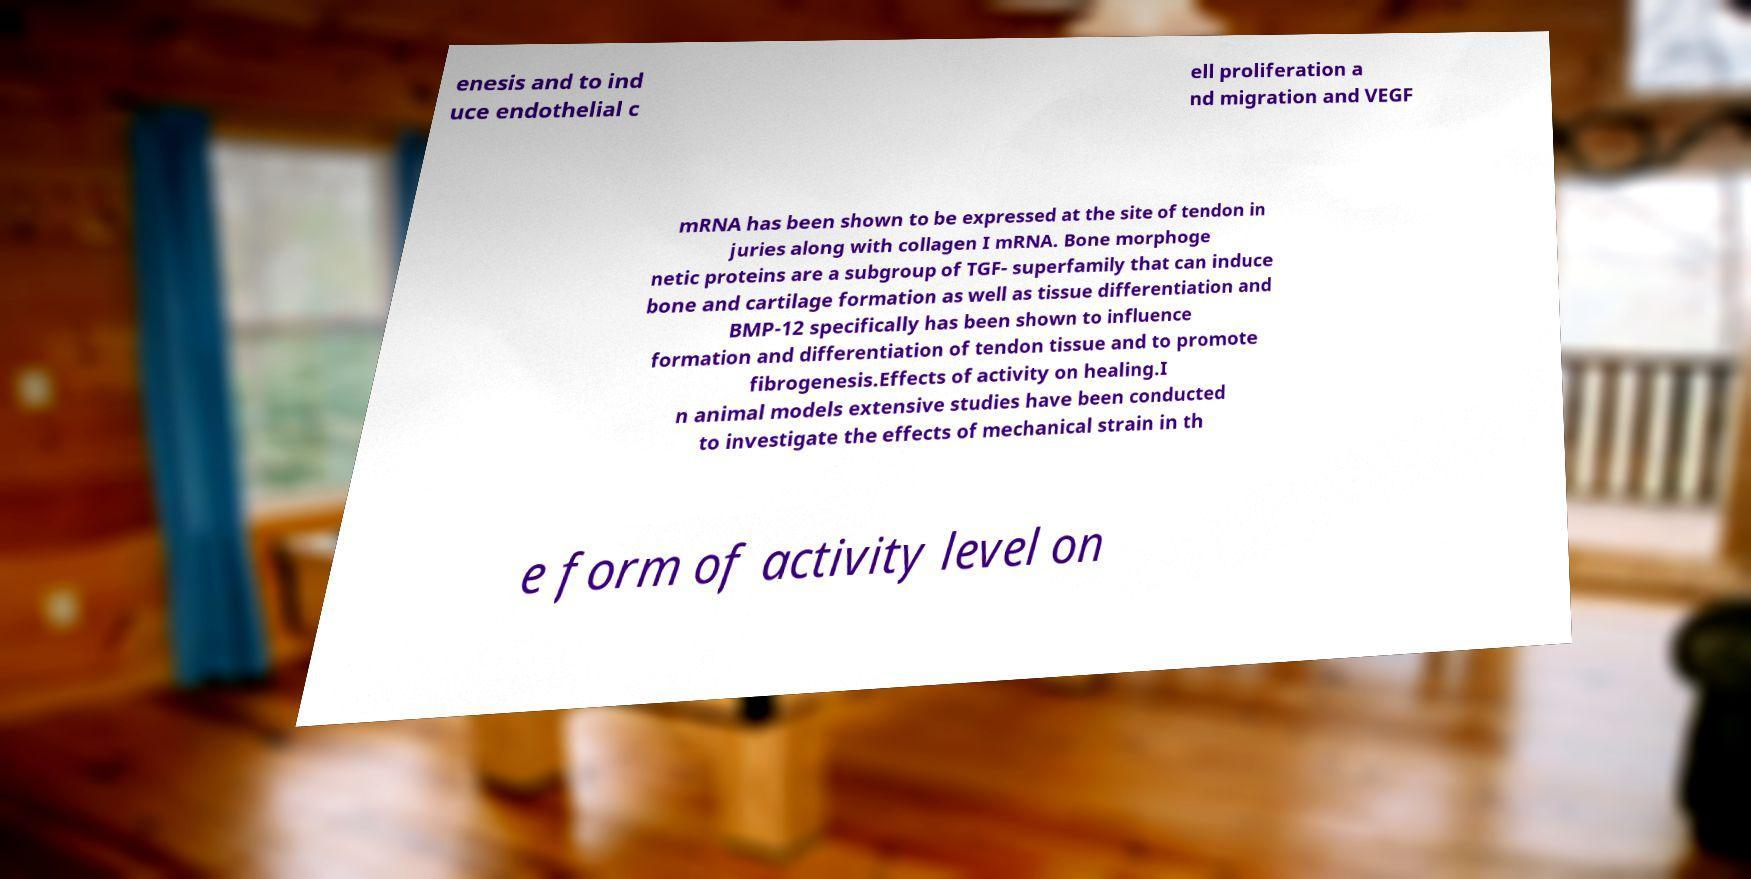Can you read and provide the text displayed in the image?This photo seems to have some interesting text. Can you extract and type it out for me? enesis and to ind uce endothelial c ell proliferation a nd migration and VEGF mRNA has been shown to be expressed at the site of tendon in juries along with collagen I mRNA. Bone morphoge netic proteins are a subgroup of TGF- superfamily that can induce bone and cartilage formation as well as tissue differentiation and BMP-12 specifically has been shown to influence formation and differentiation of tendon tissue and to promote fibrogenesis.Effects of activity on healing.I n animal models extensive studies have been conducted to investigate the effects of mechanical strain in th e form of activity level on 